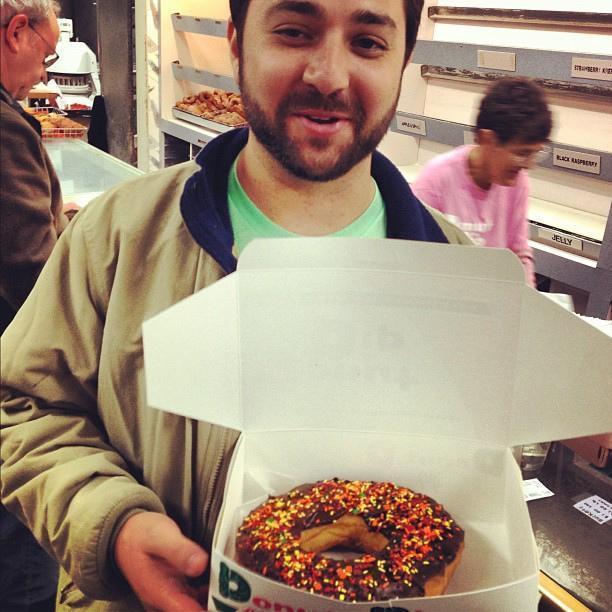What food nutrients are lacking in this food?
Make your selection and explain in format: 'Answer: answer
Rationale: rationale.'
Options: Starches, fiber, sugars, carbohydrates. Answer: fiber.
Rationale: Donuts don't have fiber. 